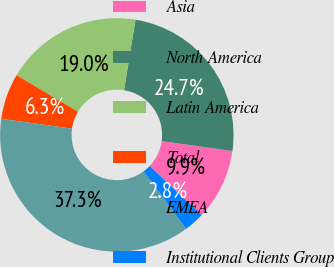Convert chart to OTSL. <chart><loc_0><loc_0><loc_500><loc_500><pie_chart><fcel>Asia<fcel>North America<fcel>Latin America<fcel>Total<fcel>EMEA<fcel>Institutional Clients Group<nl><fcel>9.86%<fcel>24.65%<fcel>19.01%<fcel>6.34%<fcel>37.32%<fcel>2.82%<nl></chart> 